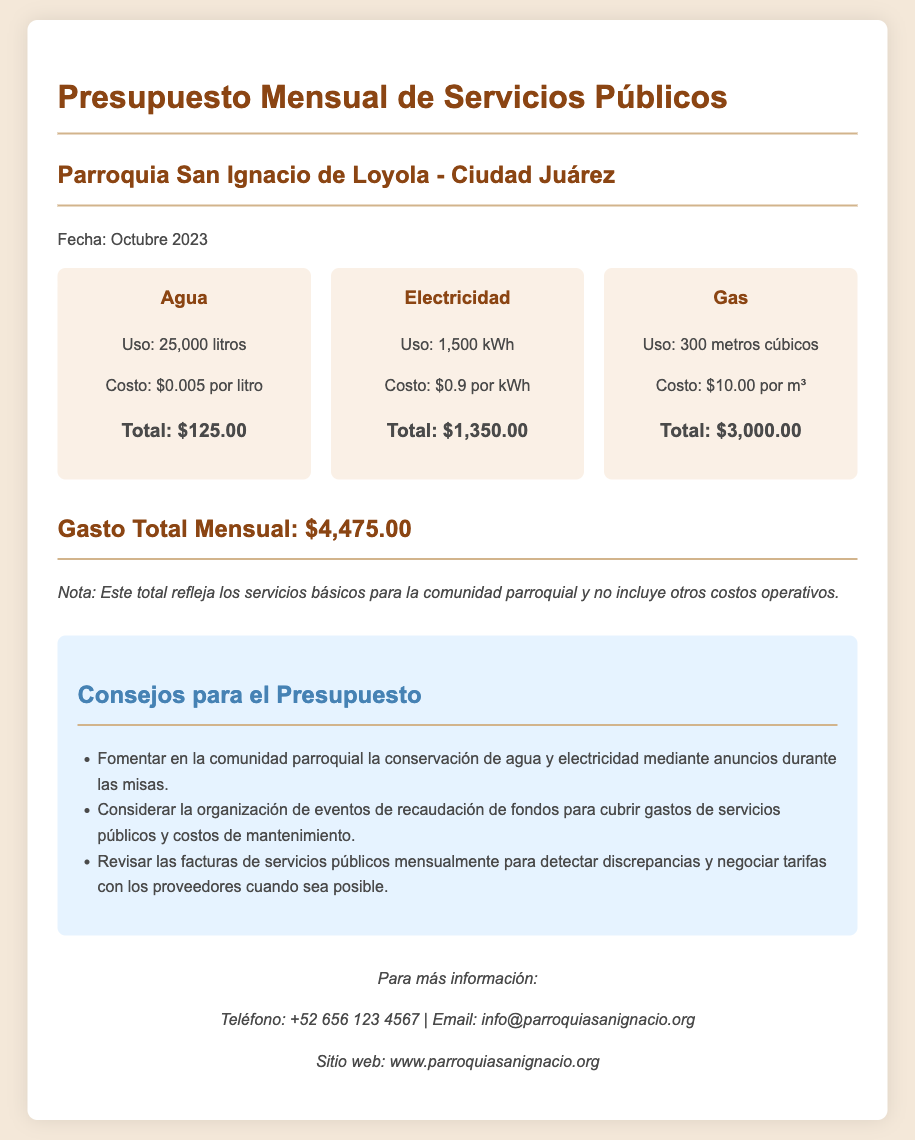¿Cuál es el costo del agua? El costo del agua es especificado como $0.005 por litro, y para 25,000 litros, el total es $125.00.
Answer: $125.00 ¿Cuántos metros cúbicos de gas se utilizaron? El documento indica que se usaron 300 metros cúbicos de gas.
Answer: 300 metros cúbicos ¿Cuánto se gastó en electricidad? El gasto en electricidad es calculado basado en 1,500 kWh a $0.9 por kWh, que suma $1,350.00 en total.
Answer: $1,350.00 ¿Cuál es el total de gastos mensuales? El total de gastos mensuales se presenta al final del documento como la suma de todos los costos, que es $4,475.00.
Answer: $4,475.00 ¿Qué consejo se da sobre las facturas de servicios públicos? El documento sugiere revisar las facturas de servicios públicos mensualmente para detectar discrepancias.
Answer: Revisar las facturas mensualmente ¿Cuántos litros de agua se utilizan en total? Se especifica que el uso total de agua es de 25,000 litros en el documento.
Answer: 25,000 litros ¿Qué tipo de documento es este? El documento es un presupuesto mensual de servicios públicos para la parroquia.
Answer: Presupuesto mensual ¿Cuál es la fecha del presupuesto? La fecha indicada en el documento para el presupuesto es Octubre 2023.
Answer: Octubre 2023 ¿Se incluye otro tipo de costos en el total? El documento menciona que el total no incluye otros costos operativos.
Answer: No 